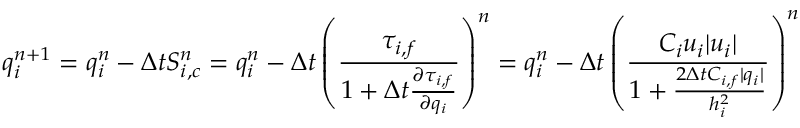<formula> <loc_0><loc_0><loc_500><loc_500>q _ { i } ^ { n + 1 } = q _ { i } ^ { n } - \Delta t S _ { i , c } ^ { n } = q _ { i } ^ { n } - \Delta t \left ( \frac { \tau _ { i , f } } { 1 + \Delta t \frac { \partial \tau _ { i , f } } { \partial q _ { i } } } \right ) ^ { n } = q _ { i } ^ { n } - \Delta t \left ( \frac { C _ { i } u _ { i } | u _ { i } | } { 1 + \frac { 2 \Delta t C _ { i , f } | q _ { i } | } { h _ { i } ^ { 2 } } } \right ) ^ { n }</formula> 